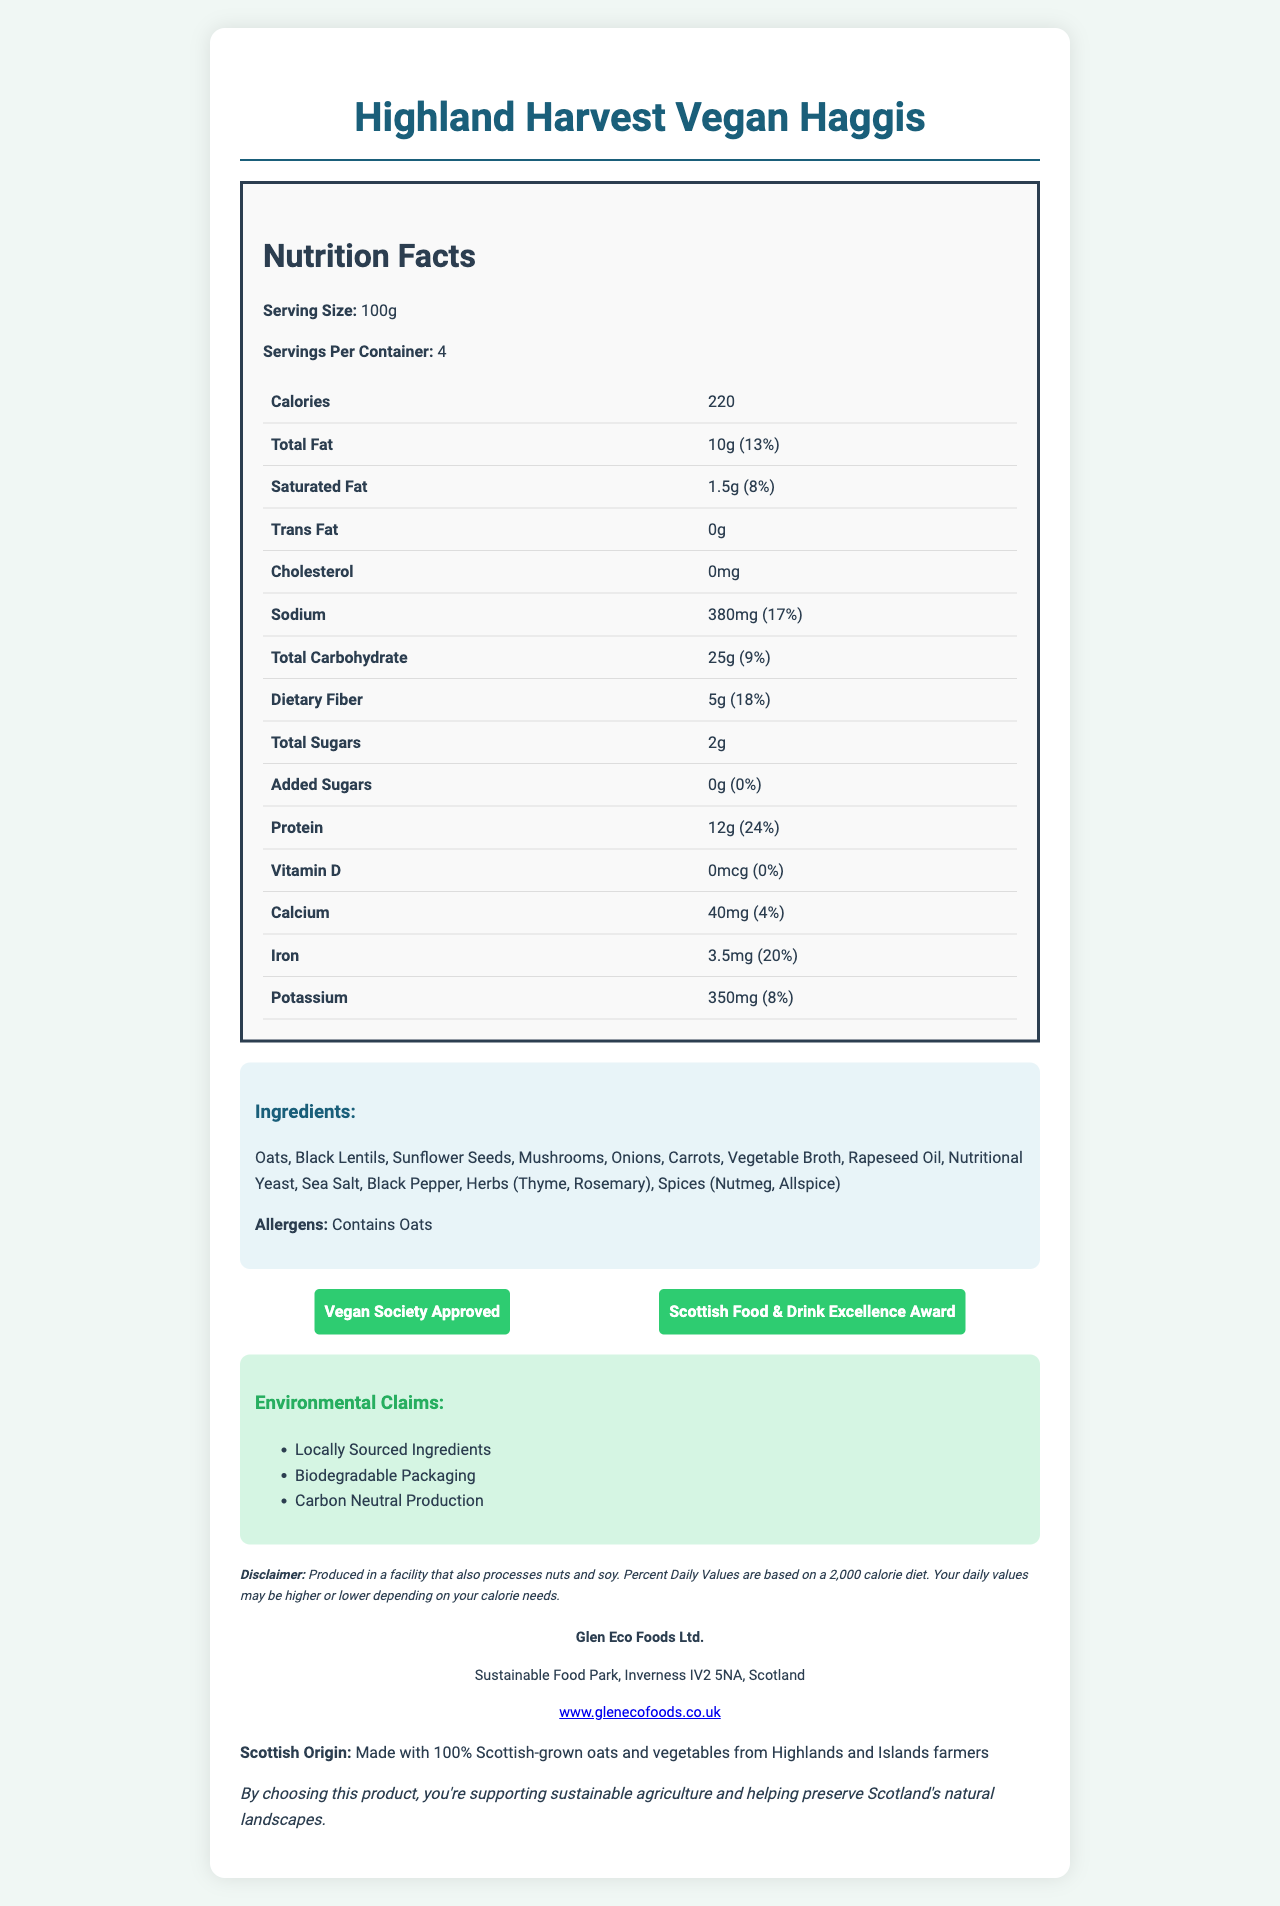what is the serving size? The serving size is listed as 100g in the nutrition facts section.
Answer: 100g how many servings are there per container? The document specifies that there are 4 servings per container.
Answer: 4 how many calories are in one serving? The calories per serving are noted as 220.
Answer: 220 what percentage of the daily value of saturated fat does one serving contain? According to the nutrition facts, one serving contains 1.5g of saturated fat, which is 8% of the daily value.
Answer: 8% what are the main ingredients of this vegan haggis? The ingredients list includes all these items.
Answer: Oats, Black Lentils, Sunflower Seeds, Mushrooms, Onions, Carrots, Vegetable Broth, Rapeseed Oil, Nutritional Yeast, Sea Salt, Black Pepper, Herbs (Thyme, Rosemary), and Spices (Nutmeg, Allspice) what is the amount of dietary fiber per serving? The nutrition facts state that each serving contains 5g of dietary fiber.
Answer: 5g is the product cholesterol-free? The nutrition facts clearly state that the product contains 0mg of cholesterol.
Answer: Yes which allergen is present in the product? A. Nuts B. Soy C. Oats D. Wheat The allergen information specifies that the product contains oats.
Answer: C: Oats what certifications does the product have? A. Vegan Society Approved B. Organic C. Scottish Food & Drink Excellence Award D. Both A and C The certifications listed include "Vegan Society Approved" and "Scottish Food & Drink Excellence Award."
Answer: D: Both A and C how does the product support environmental sustainability? The document lists these environmental claims under the environmental claims section.
Answer: Locally Sourced Ingredients, Biodegradable Packaging, Carbon Neutral Production where is Glen Eco Foods Ltd. located? The manufacturer information provides this address.
Answer: Sustainable Food Park, Inverness IV2 5NA, Scotland what is the company's website? The manufacturer's website is listed as www.glenecofoods.co.uk.
Answer: www.glenecofoods.co.uk does the product contain any sugars? The nutrition facts show that there are 2g of total sugars per serving.
Answer: Yes what is the main idea of the document? The document includes various sections such as nutrition facts, ingredients, allergens, certifications, environmental claims, and manufacturer information, summarizing the product's features and benefits.
Answer: The document provides detailed nutritional information, ingredients, certifications, and environmental claims for Highland Harvest Vegan Haggis, a Scottish-made plant-based haggis alternative. how much iron does one serving provide? The nutrition facts indicate that one serving provides 3.5mg of iron.
Answer: 3.5mg can you determine the exact production process of this vegan haggis from the document? The document provides nutritional facts, ingredients, and claims but does not describe the specific production process.
Answer: Not enough information does the product have more than 10% of the daily value for dietary fiber? One serving has 18% of the daily value for dietary fiber, which is more than 10%.
Answer: Yes what is the potential environmental impact benefit of choosing this product? The sustainability note mentions these benefits as a result of choosing this product.
Answer: Supporting sustainable agriculture and helping preserve Scotland's natural landscapes is there any trans fat in the product? True or False The nutrition facts declare that there is 0g of trans fat in the product.
Answer: False 